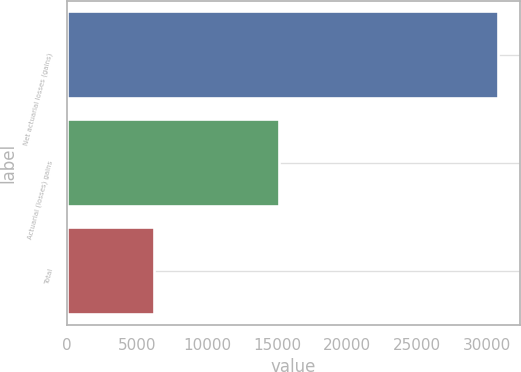<chart> <loc_0><loc_0><loc_500><loc_500><bar_chart><fcel>Net actuarial losses (gains)<fcel>Actuarial (losses) gains<fcel>Total<nl><fcel>30759<fcel>15134<fcel>6226<nl></chart> 